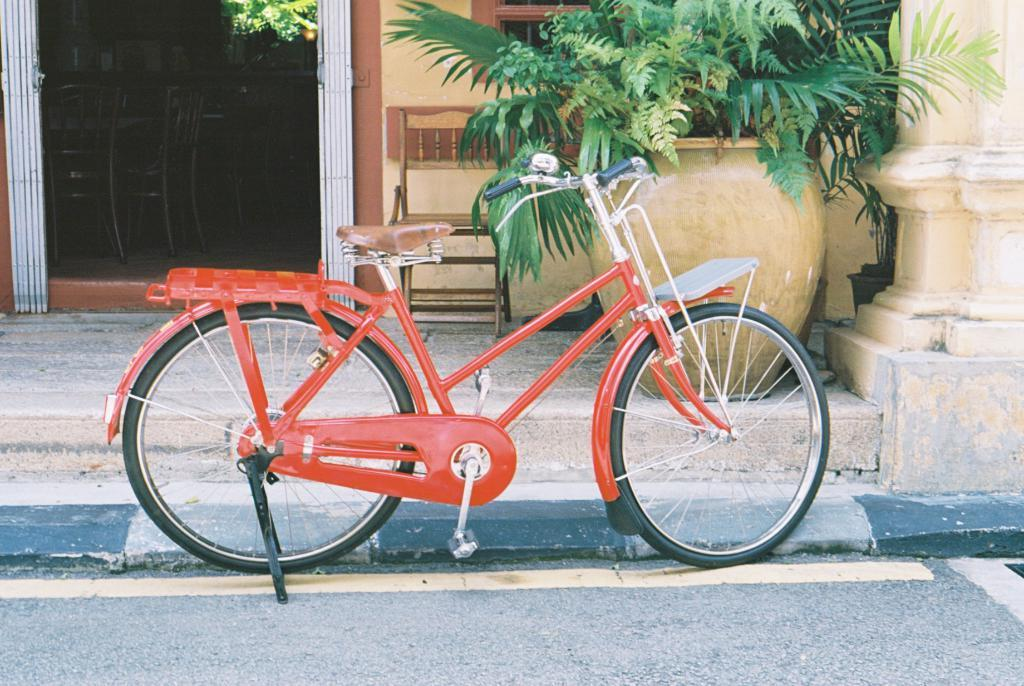What is the main object in the foreground of the image? There is a bicycle on the road in the image. What can be seen in the background of the image? In the background of the image, there are chairs, a window, a gate, plants, and a pillar. Can you describe the setting of the image? The image appears to be set outdoors, with a road and various background elements. What type of vein is visible on the bicycle in the image? There are no veins visible on the bicycle in the image; it is a mechanical object. Can you describe the wave pattern on the plants in the background of the image? There is no wave pattern on the plants in the image; they are depicted as individual plants. 